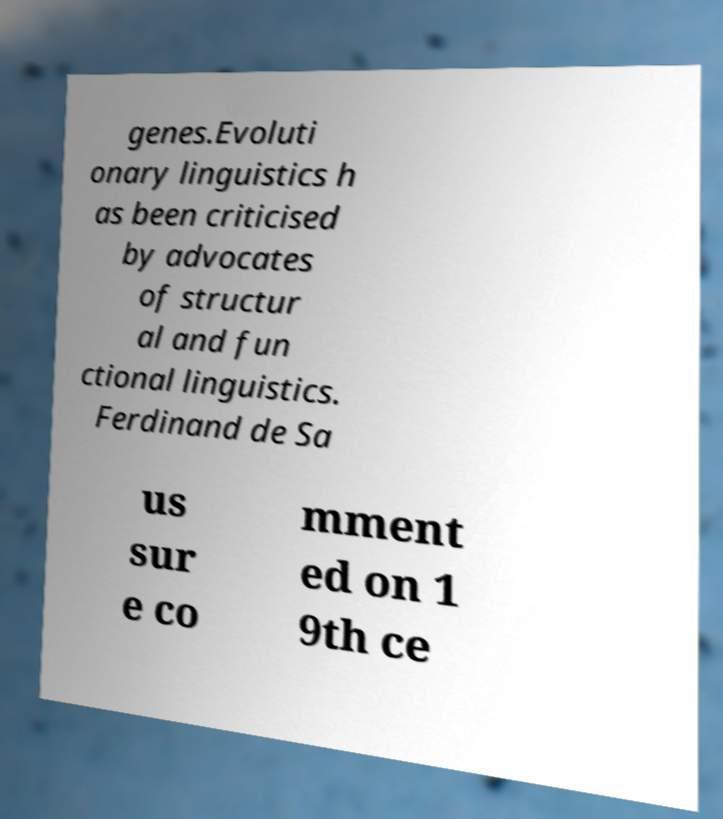I need the written content from this picture converted into text. Can you do that? genes.Evoluti onary linguistics h as been criticised by advocates of structur al and fun ctional linguistics. Ferdinand de Sa us sur e co mment ed on 1 9th ce 